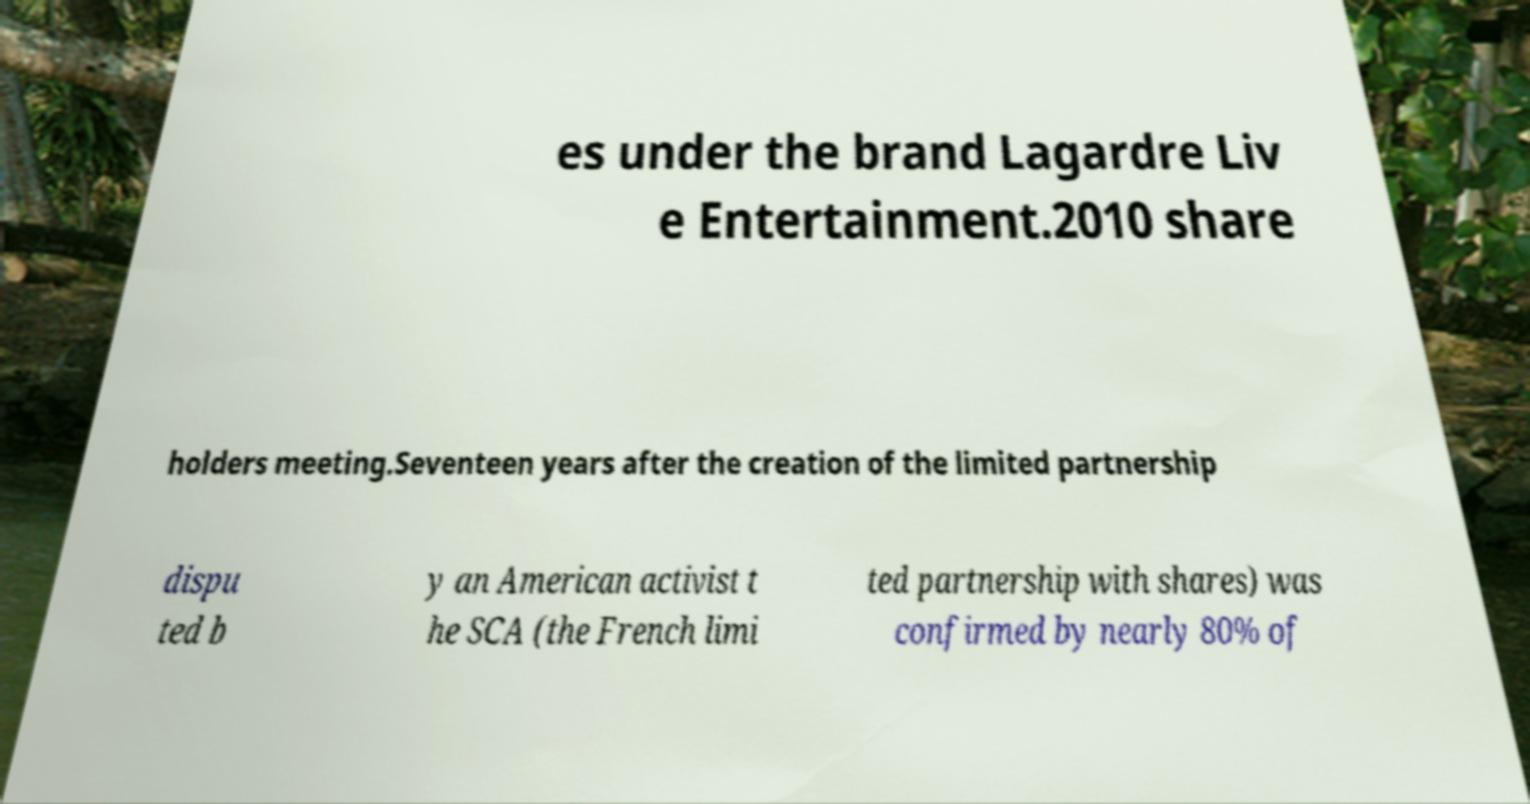There's text embedded in this image that I need extracted. Can you transcribe it verbatim? es under the brand Lagardre Liv e Entertainment.2010 share holders meeting.Seventeen years after the creation of the limited partnership dispu ted b y an American activist t he SCA (the French limi ted partnership with shares) was confirmed by nearly 80% of 